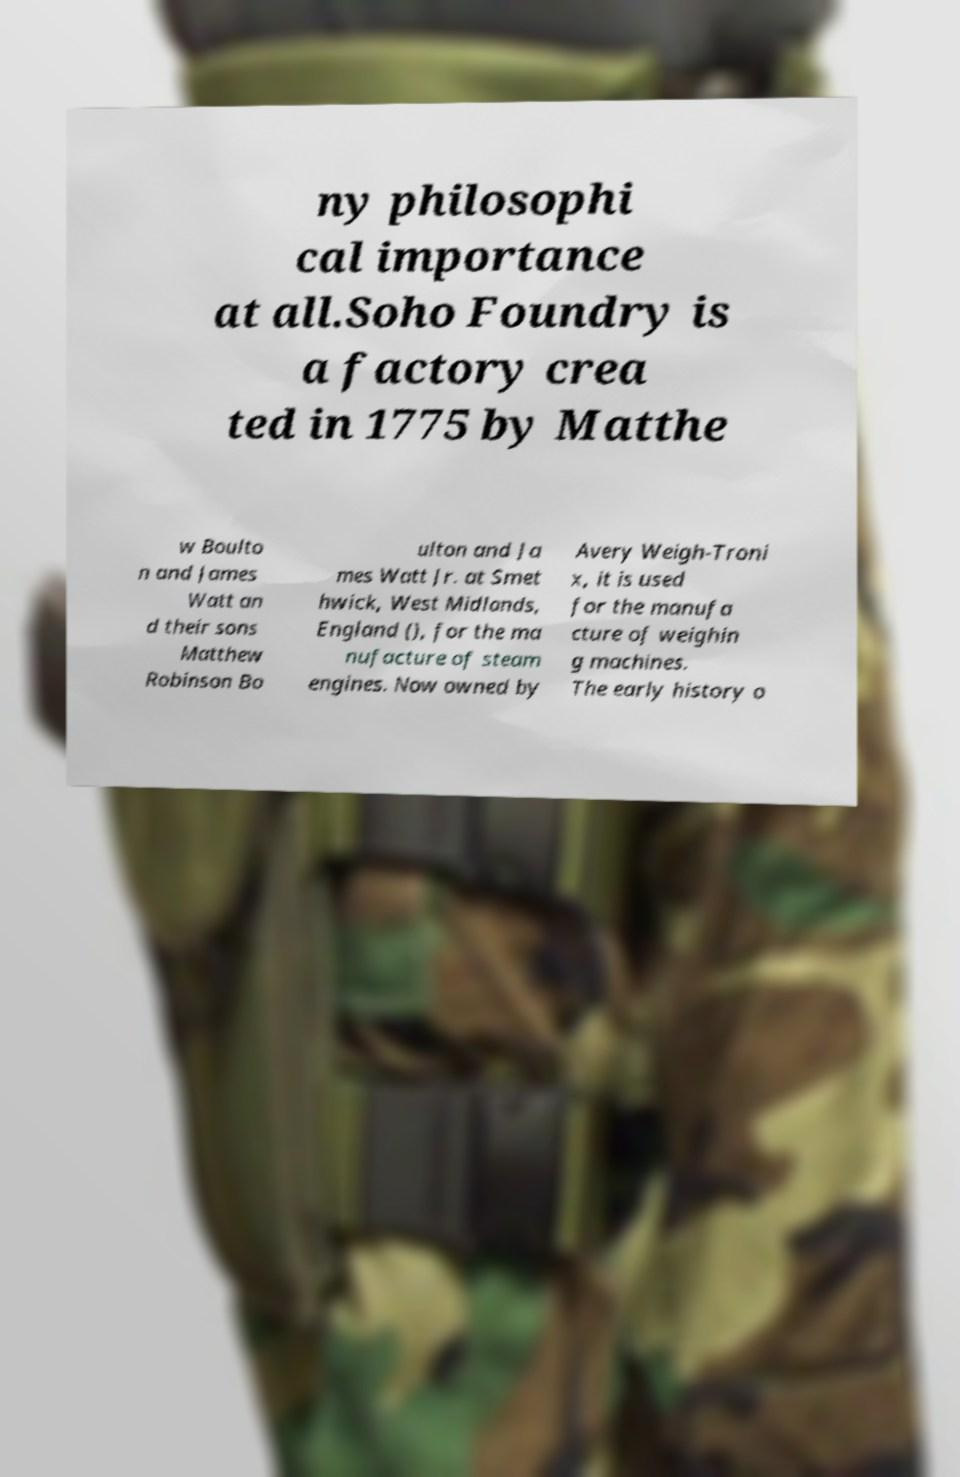Could you extract and type out the text from this image? ny philosophi cal importance at all.Soho Foundry is a factory crea ted in 1775 by Matthe w Boulto n and James Watt an d their sons Matthew Robinson Bo ulton and Ja mes Watt Jr. at Smet hwick, West Midlands, England (), for the ma nufacture of steam engines. Now owned by Avery Weigh-Troni x, it is used for the manufa cture of weighin g machines. The early history o 